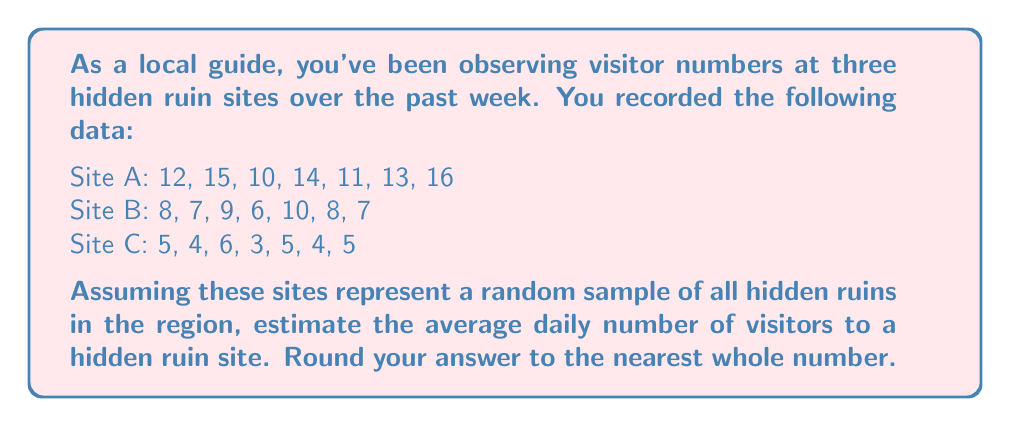Can you solve this math problem? To estimate the average daily number of visitors to a hidden ruin site, we'll follow these steps:

1. Calculate the mean for each site:

Site A: $\frac{12 + 15 + 10 + 14 + 11 + 13 + 16}{7} = \frac{91}{7} = 13$
Site B: $\frac{8 + 7 + 9 + 6 + 10 + 8 + 7}{7} = \frac{55}{7} \approx 7.86$
Site C: $\frac{5 + 4 + 6 + 3 + 5 + 4 + 5}{7} = \frac{32}{7} \approx 4.57$

2. Calculate the overall mean of the three sites:

$$\text{Overall Mean} = \frac{13 + 7.86 + 4.57}{3} \approx 8.48$$

3. Round to the nearest whole number:

$$8.48 \approx 8$$

Since these sites represent a random sample of all hidden ruins in the region, we can use this sample mean as an estimate for the population mean (average daily visitors to any hidden ruin site in the region).
Answer: 8 visitors 